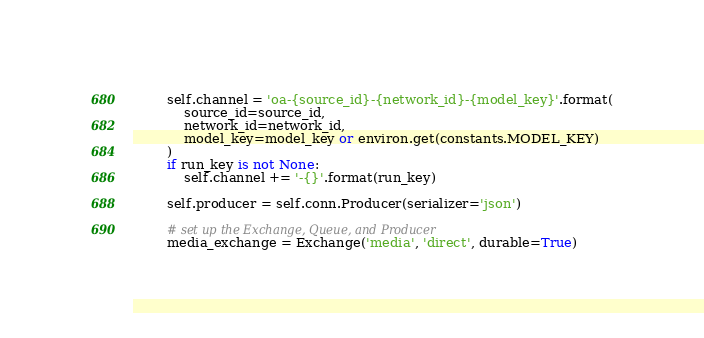<code> <loc_0><loc_0><loc_500><loc_500><_Python_>        self.channel = 'oa-{source_id}-{network_id}-{model_key}'.format(
            source_id=source_id,
            network_id=network_id,
            model_key=model_key or environ.get(constants.MODEL_KEY)
        )
        if run_key is not None:
            self.channel += '-{}'.format(run_key)

        self.producer = self.conn.Producer(serializer='json')

        # set up the Exchange, Queue, and Producer
        media_exchange = Exchange('media', 'direct', durable=True)</code> 